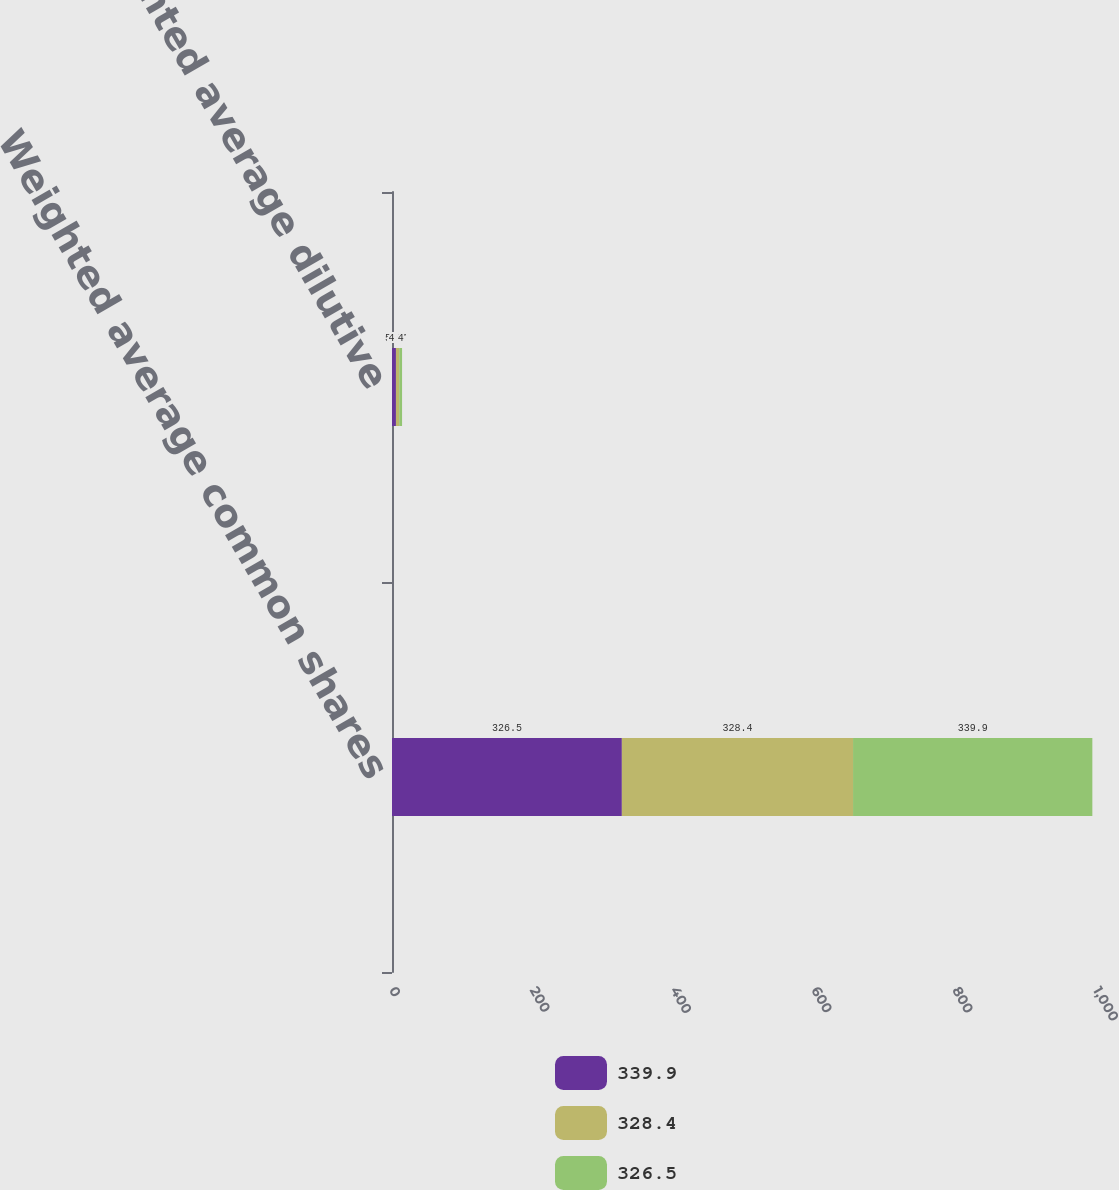Convert chart to OTSL. <chart><loc_0><loc_0><loc_500><loc_500><stacked_bar_chart><ecel><fcel>Weighted average common shares<fcel>Weighted average dilutive<nl><fcel>339.9<fcel>326.5<fcel>5.6<nl><fcel>328.4<fcel>328.4<fcel>4.7<nl><fcel>326.5<fcel>339.9<fcel>4<nl></chart> 